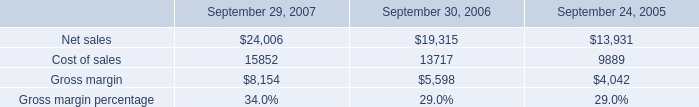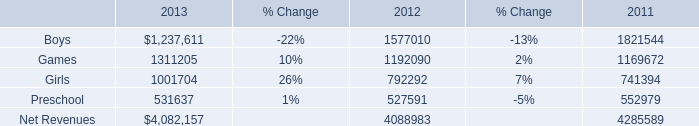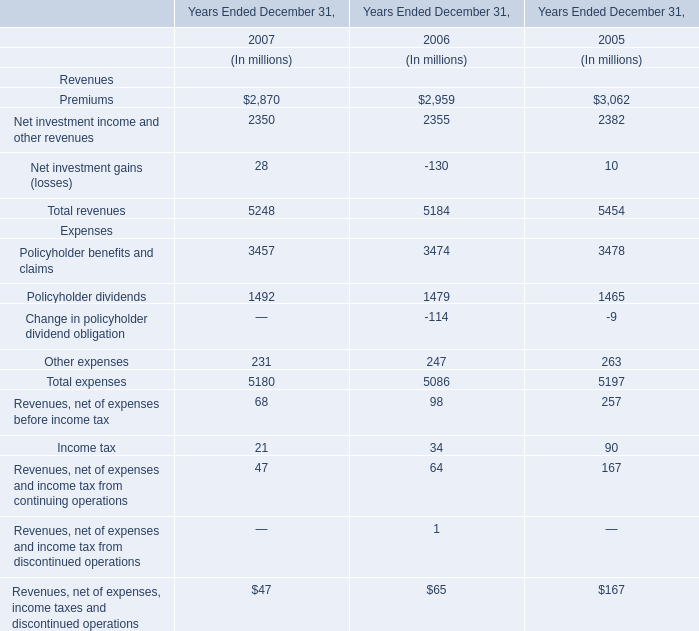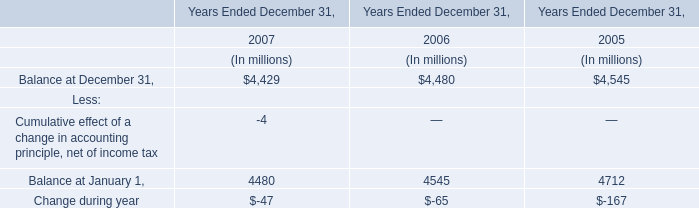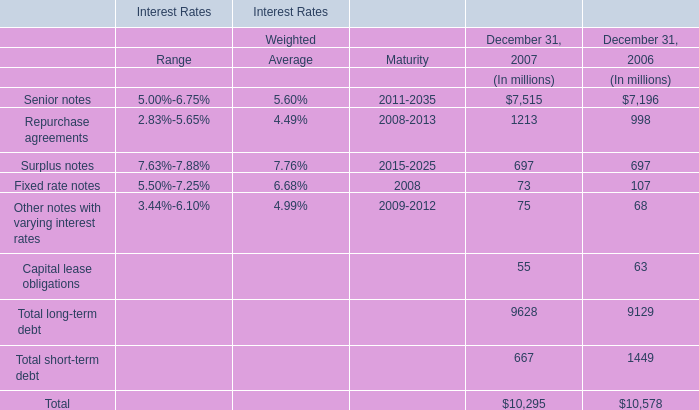what was the percentage sales change from 2006 to 2007? 
Computations: ((24006 - 19315) / 19315)
Answer: 0.24287. 